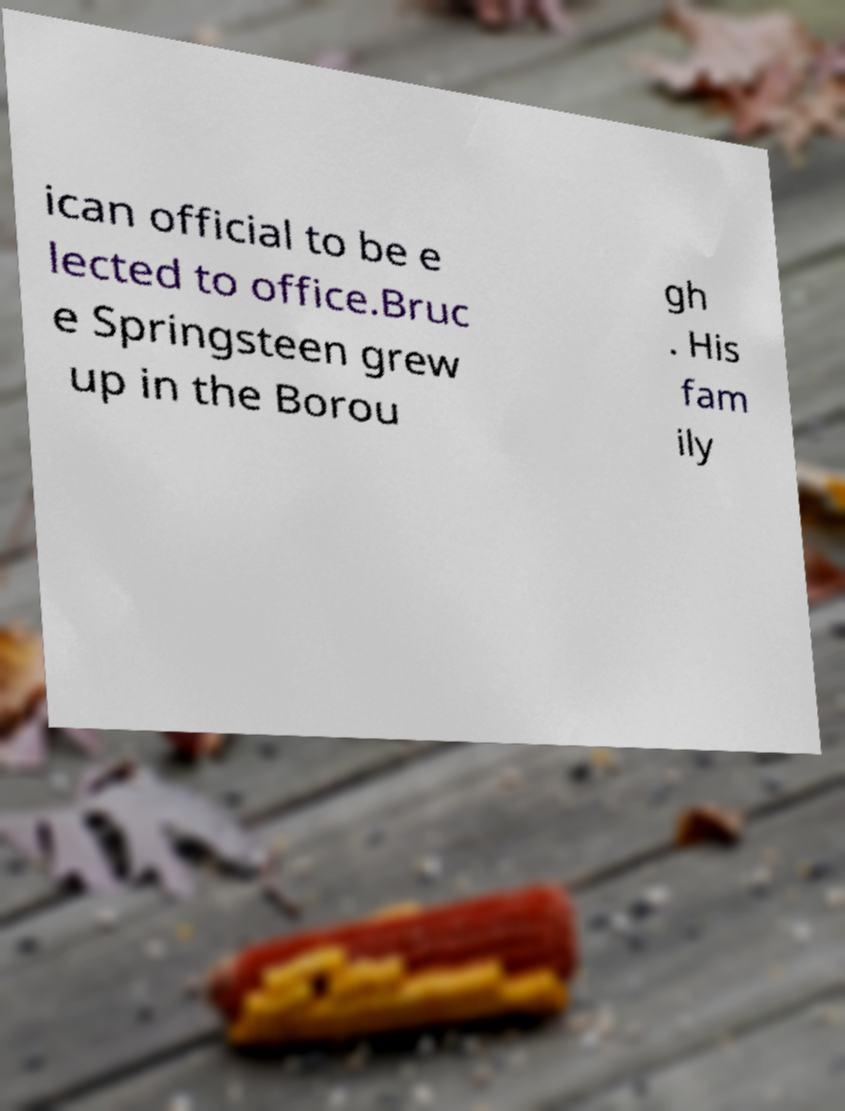I need the written content from this picture converted into text. Can you do that? ican official to be e lected to office.Bruc e Springsteen grew up in the Borou gh . His fam ily 